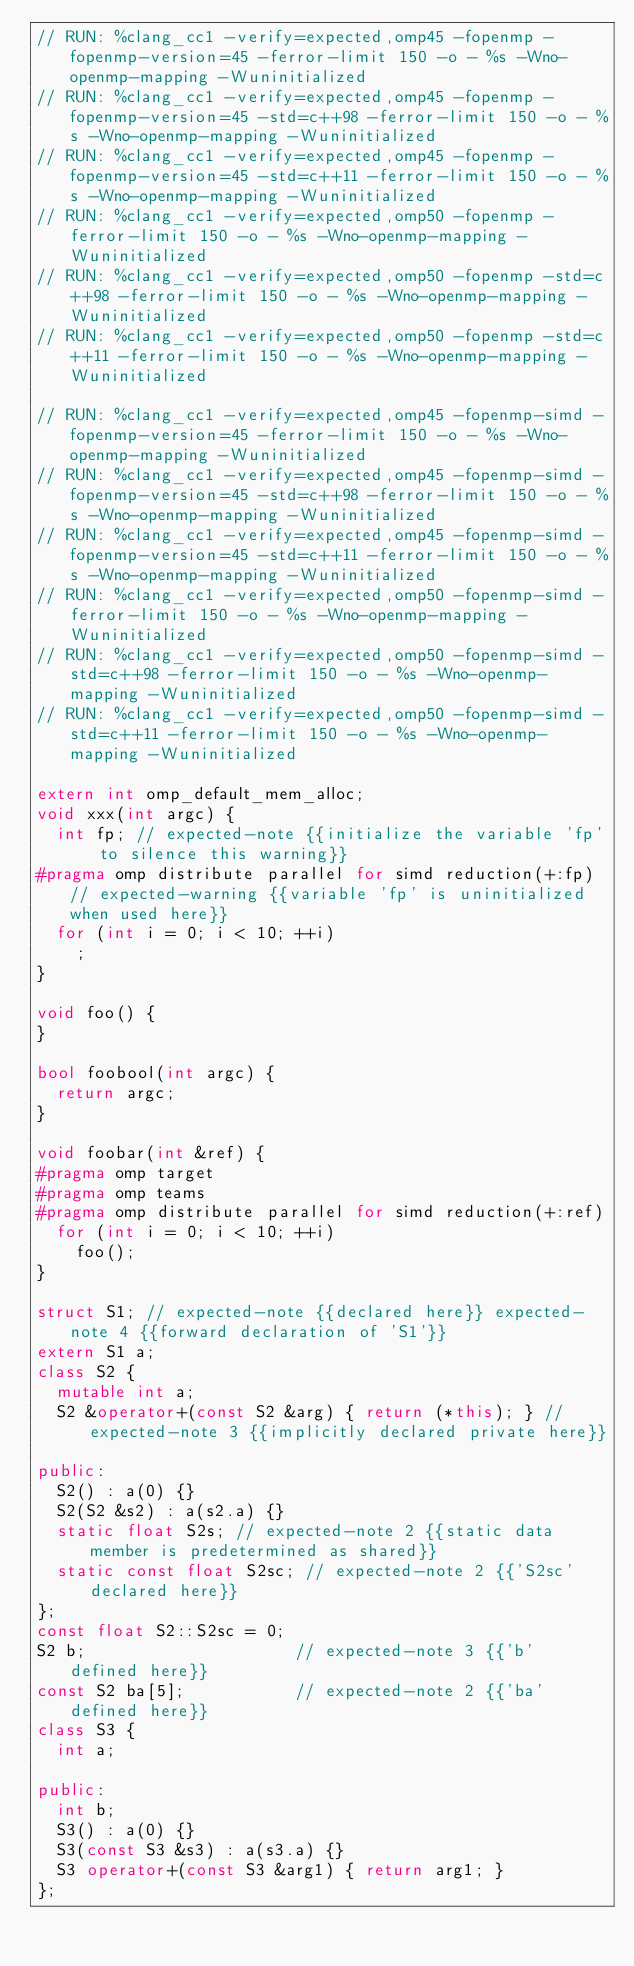Convert code to text. <code><loc_0><loc_0><loc_500><loc_500><_C++_>// RUN: %clang_cc1 -verify=expected,omp45 -fopenmp -fopenmp-version=45 -ferror-limit 150 -o - %s -Wno-openmp-mapping -Wuninitialized
// RUN: %clang_cc1 -verify=expected,omp45 -fopenmp -fopenmp-version=45 -std=c++98 -ferror-limit 150 -o - %s -Wno-openmp-mapping -Wuninitialized
// RUN: %clang_cc1 -verify=expected,omp45 -fopenmp -fopenmp-version=45 -std=c++11 -ferror-limit 150 -o - %s -Wno-openmp-mapping -Wuninitialized
// RUN: %clang_cc1 -verify=expected,omp50 -fopenmp -ferror-limit 150 -o - %s -Wno-openmp-mapping -Wuninitialized
// RUN: %clang_cc1 -verify=expected,omp50 -fopenmp -std=c++98 -ferror-limit 150 -o - %s -Wno-openmp-mapping -Wuninitialized
// RUN: %clang_cc1 -verify=expected,omp50 -fopenmp -std=c++11 -ferror-limit 150 -o - %s -Wno-openmp-mapping -Wuninitialized

// RUN: %clang_cc1 -verify=expected,omp45 -fopenmp-simd -fopenmp-version=45 -ferror-limit 150 -o - %s -Wno-openmp-mapping -Wuninitialized
// RUN: %clang_cc1 -verify=expected,omp45 -fopenmp-simd -fopenmp-version=45 -std=c++98 -ferror-limit 150 -o - %s -Wno-openmp-mapping -Wuninitialized
// RUN: %clang_cc1 -verify=expected,omp45 -fopenmp-simd -fopenmp-version=45 -std=c++11 -ferror-limit 150 -o - %s -Wno-openmp-mapping -Wuninitialized
// RUN: %clang_cc1 -verify=expected,omp50 -fopenmp-simd -ferror-limit 150 -o - %s -Wno-openmp-mapping -Wuninitialized
// RUN: %clang_cc1 -verify=expected,omp50 -fopenmp-simd -std=c++98 -ferror-limit 150 -o - %s -Wno-openmp-mapping -Wuninitialized
// RUN: %clang_cc1 -verify=expected,omp50 -fopenmp-simd -std=c++11 -ferror-limit 150 -o - %s -Wno-openmp-mapping -Wuninitialized

extern int omp_default_mem_alloc;
void xxx(int argc) {
  int fp; // expected-note {{initialize the variable 'fp' to silence this warning}}
#pragma omp distribute parallel for simd reduction(+:fp) // expected-warning {{variable 'fp' is uninitialized when used here}}
  for (int i = 0; i < 10; ++i)
    ;
}

void foo() {
}

bool foobool(int argc) {
  return argc;
}

void foobar(int &ref) {
#pragma omp target
#pragma omp teams
#pragma omp distribute parallel for simd reduction(+:ref)
  for (int i = 0; i < 10; ++i)
    foo();
}

struct S1; // expected-note {{declared here}} expected-note 4 {{forward declaration of 'S1'}}
extern S1 a;
class S2 {
  mutable int a;
  S2 &operator+(const S2 &arg) { return (*this); } // expected-note 3 {{implicitly declared private here}}

public:
  S2() : a(0) {}
  S2(S2 &s2) : a(s2.a) {}
  static float S2s; // expected-note 2 {{static data member is predetermined as shared}}
  static const float S2sc; // expected-note 2 {{'S2sc' declared here}}
};
const float S2::S2sc = 0;
S2 b;                     // expected-note 3 {{'b' defined here}}
const S2 ba[5];           // expected-note 2 {{'ba' defined here}}
class S3 {
  int a;

public:
  int b;
  S3() : a(0) {}
  S3(const S3 &s3) : a(s3.a) {}
  S3 operator+(const S3 &arg1) { return arg1; }
};</code> 